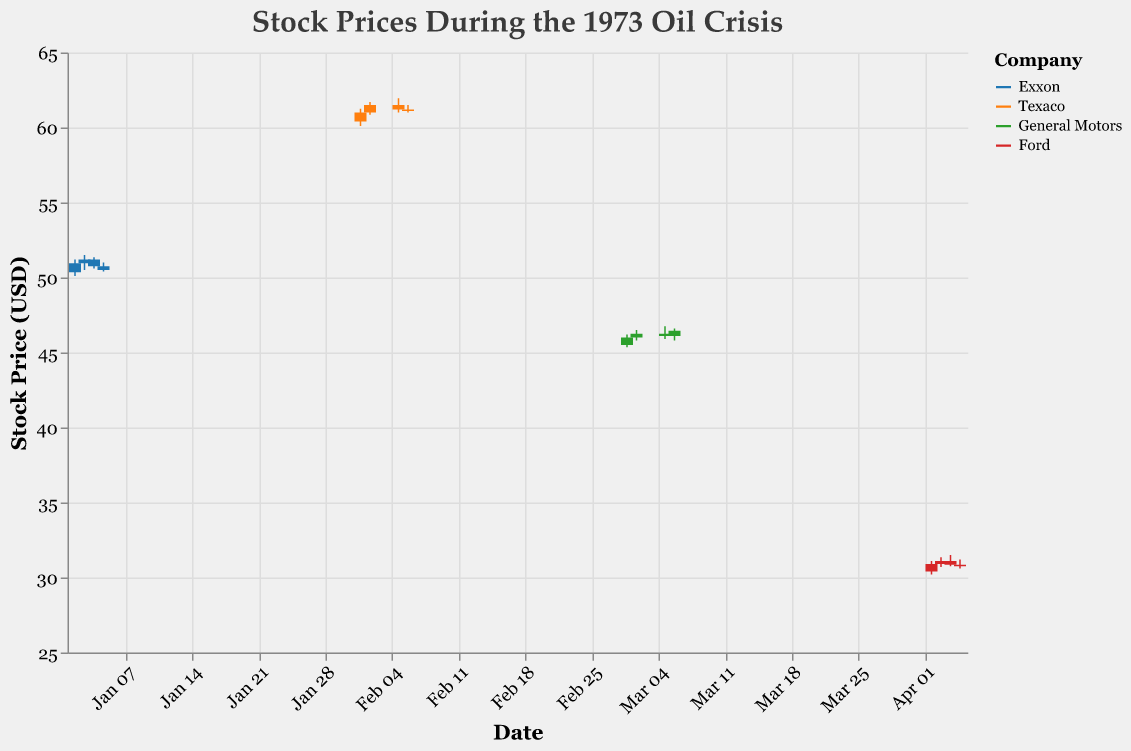What is the title of the figure? The title can be found at the top of the figure. It states the main topic the figure is visualizing.
Answer: Stock Prices During the 1973 Oil Crisis Which company had the highest closing price and on what date? Observe the candlestick plot and identify the highest "Close" price. Then, look at the corresponding date and company.
Answer: Texaco on February 2, 1973 What is the range of stock prices displayed on the y-axis? Look at the y-axis and note the minimum and maximum values.
Answer: 25 to 65 USD Which company shows the greatest variation in stock prices during the displayed period? Compare the range of prices (difference between high and low) for each company.
Answer: Exxon How many companies' stock prices are depicted in the figure? Look at the colors represented and the legend, which shows a list of companies.
Answer: Four companies What trend can be observed for Exxon's stock prices over the displayed period? Examine the candles for Exxon from left to right and note the opening and closing prices.
Answer: Fluctuating but slightly downward Compare the opening price of Ford on April 2 and April 3. Which day was higher and by how much? Check the "Open" values for both dates and calculate the difference.
Answer: April 3 was higher by 0.50 How would you describe the candlestick for General Motors on March 2, 1973? Identify the "Open," "Close," "High," and "Low" values for General Motors on that date and describe the candlestick shape.
Answer: Small body candle with a higher close than open, moderate wicks What was the average closing price for Texaco in February 1973? Add the closing prices for Texaco on all February dates and divide by the number of dates.
Answer: 61.20 USD Which company experienced the least fluctuation in stock prices based on the candlestick plots? Compare the lengths of the candles and wicks for each company. The one with the shortest overall will show the least fluctuation.
Answer: General Motors 